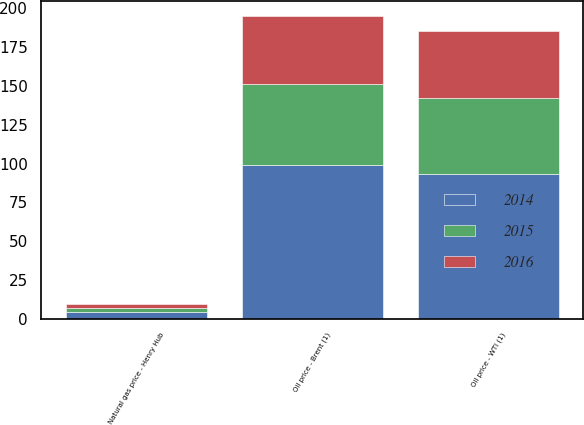Convert chart to OTSL. <chart><loc_0><loc_0><loc_500><loc_500><stacked_bar_chart><ecel><fcel>Oil price - WTI (1)<fcel>Oil price - Brent (1)<fcel>Natural gas price - Henry Hub<nl><fcel>2016<fcel>43.14<fcel>43.55<fcel>2.52<nl><fcel>2015<fcel>48.69<fcel>52.36<fcel>2.63<nl><fcel>2014<fcel>93.37<fcel>99.04<fcel>4.39<nl></chart> 